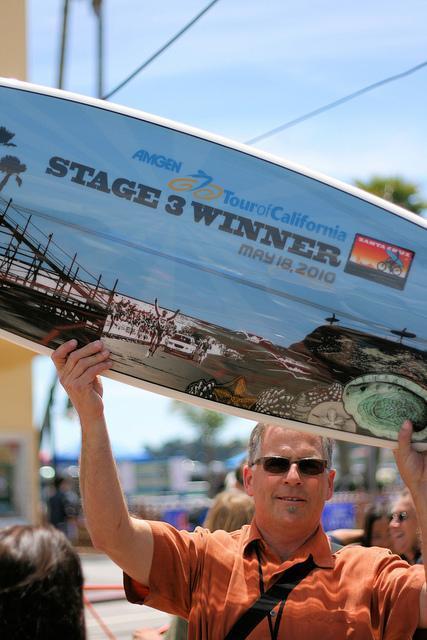How many people can you see?
Give a very brief answer. 2. How many white dogs are there?
Give a very brief answer. 0. 